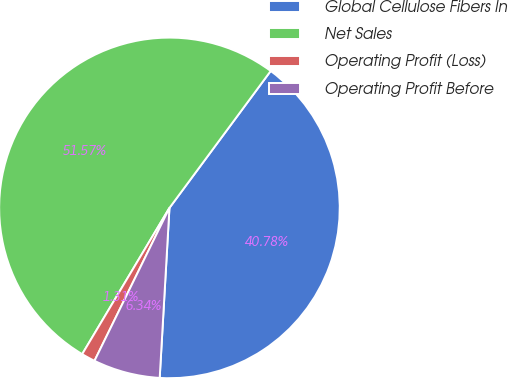Convert chart. <chart><loc_0><loc_0><loc_500><loc_500><pie_chart><fcel>Global Cellulose Fibers In<fcel>Net Sales<fcel>Operating Profit (Loss)<fcel>Operating Profit Before<nl><fcel>40.78%<fcel>51.57%<fcel>1.31%<fcel>6.34%<nl></chart> 